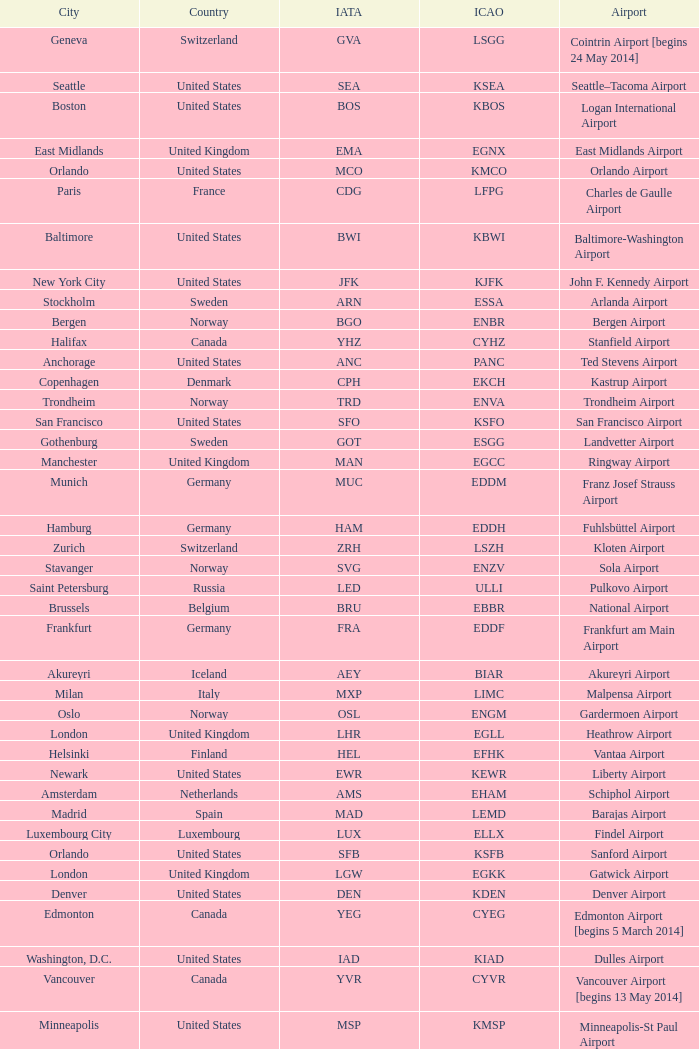Give me the full table as a dictionary. {'header': ['City', 'Country', 'IATA', 'ICAO', 'Airport'], 'rows': [['Geneva', 'Switzerland', 'GVA', 'LSGG', 'Cointrin Airport [begins 24 May 2014]'], ['Seattle', 'United States', 'SEA', 'KSEA', 'Seattle–Tacoma Airport'], ['Boston', 'United States', 'BOS', 'KBOS', 'Logan International Airport'], ['East Midlands', 'United Kingdom', 'EMA', 'EGNX', 'East Midlands Airport'], ['Orlando', 'United States', 'MCO', 'KMCO', 'Orlando Airport'], ['Paris', 'France', 'CDG', 'LFPG', 'Charles de Gaulle Airport'], ['Baltimore', 'United States', 'BWI', 'KBWI', 'Baltimore-Washington Airport'], ['New York City', 'United States', 'JFK', 'KJFK', 'John F. Kennedy Airport'], ['Stockholm', 'Sweden', 'ARN', 'ESSA', 'Arlanda Airport'], ['Bergen', 'Norway', 'BGO', 'ENBR', 'Bergen Airport'], ['Halifax', 'Canada', 'YHZ', 'CYHZ', 'Stanfield Airport'], ['Anchorage', 'United States', 'ANC', 'PANC', 'Ted Stevens Airport'], ['Copenhagen', 'Denmark', 'CPH', 'EKCH', 'Kastrup Airport'], ['Trondheim', 'Norway', 'TRD', 'ENVA', 'Trondheim Airport'], ['San Francisco', 'United States', 'SFO', 'KSFO', 'San Francisco Airport'], ['Gothenburg', 'Sweden', 'GOT', 'ESGG', 'Landvetter Airport'], ['Manchester', 'United Kingdom', 'MAN', 'EGCC', 'Ringway Airport'], ['Munich', 'Germany', 'MUC', 'EDDM', 'Franz Josef Strauss Airport'], ['Hamburg', 'Germany', 'HAM', 'EDDH', 'Fuhlsbüttel Airport'], ['Zurich', 'Switzerland', 'ZRH', 'LSZH', 'Kloten Airport'], ['Stavanger', 'Norway', 'SVG', 'ENZV', 'Sola Airport'], ['Saint Petersburg', 'Russia', 'LED', 'ULLI', 'Pulkovo Airport'], ['Brussels', 'Belgium', 'BRU', 'EBBR', 'National Airport'], ['Frankfurt', 'Germany', 'FRA', 'EDDF', 'Frankfurt am Main Airport'], ['Akureyri', 'Iceland', 'AEY', 'BIAR', 'Akureyri Airport'], ['Milan', 'Italy', 'MXP', 'LIMC', 'Malpensa Airport'], ['Oslo', 'Norway', 'OSL', 'ENGM', 'Gardermoen Airport'], ['London', 'United Kingdom', 'LHR', 'EGLL', 'Heathrow Airport'], ['Helsinki', 'Finland', 'HEL', 'EFHK', 'Vantaa Airport'], ['Newark', 'United States', 'EWR', 'KEWR', 'Liberty Airport'], ['Amsterdam', 'Netherlands', 'AMS', 'EHAM', 'Schiphol Airport'], ['Madrid', 'Spain', 'MAD', 'LEMD', 'Barajas Airport'], ['Luxembourg City', 'Luxembourg', 'LUX', 'ELLX', 'Findel Airport'], ['Orlando', 'United States', 'SFB', 'KSFB', 'Sanford Airport'], ['London', 'United Kingdom', 'LGW', 'EGKK', 'Gatwick Airport'], ['Denver', 'United States', 'DEN', 'KDEN', 'Denver Airport'], ['Edmonton', 'Canada', 'YEG', 'CYEG', 'Edmonton Airport [begins 5 March 2014]'], ['Washington, D.C.', 'United States', 'IAD', 'KIAD', 'Dulles Airport'], ['Vancouver', 'Canada', 'YVR', 'CYVR', 'Vancouver Airport [begins 13 May 2014]'], ['Minneapolis', 'United States', 'MSP', 'KMSP', 'Minneapolis-St Paul Airport'], ['Toronto', 'Canada', 'YYZ', 'CYYZ', 'Pearson Airport'], ['Liège', 'Belgium', 'LGG', 'EBLG', 'Liège Airport'], ['Glasgow', 'United Kingdom', 'GLA', 'EGPF', 'International Airport'], ['Reykjavík', 'Iceland', 'KEF', 'BIKF', 'Keflavik Airport'], ['Barcelona', 'Spain', 'BCN', 'LEBL', 'El Prat Airport'], ['Billund', 'Denmark', 'BLL', 'EKBI', 'Billund Airport']]} What Airport's IATA is SEA? Seattle–Tacoma Airport. 